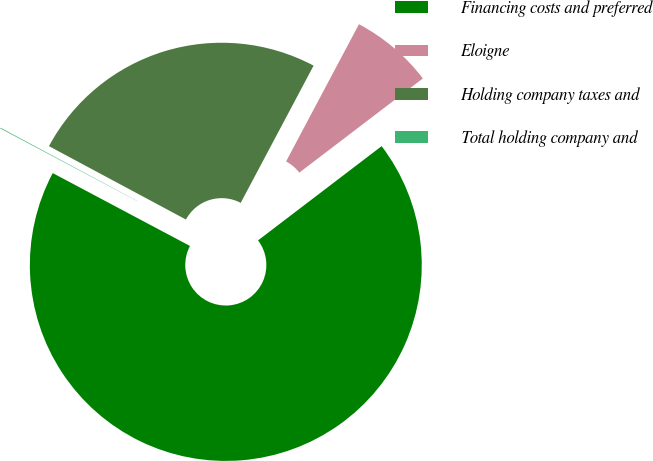<chart> <loc_0><loc_0><loc_500><loc_500><pie_chart><fcel>Financing costs and preferred<fcel>Eloigne<fcel>Holding company taxes and<fcel>Total holding company and<nl><fcel>68.13%<fcel>6.86%<fcel>24.94%<fcel>0.06%<nl></chart> 